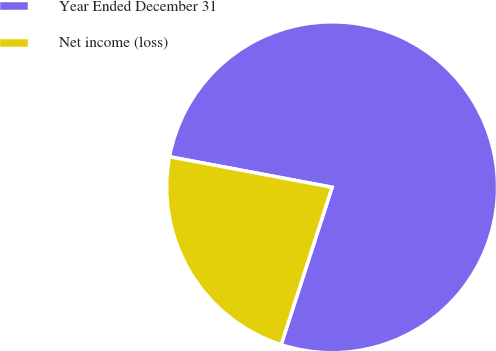<chart> <loc_0><loc_0><loc_500><loc_500><pie_chart><fcel>Year Ended December 31<fcel>Net income (loss)<nl><fcel>77.03%<fcel>22.97%<nl></chart> 